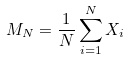Convert formula to latex. <formula><loc_0><loc_0><loc_500><loc_500>M _ { N } = \frac { 1 } { N } \sum _ { i = 1 } ^ { N } X _ { i }</formula> 